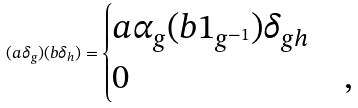<formula> <loc_0><loc_0><loc_500><loc_500>( a \delta _ { g } ) ( b \delta _ { h } ) = \begin{cases} a \alpha _ { g } ( b 1 _ { g ^ { - 1 } } ) \delta _ { g h } & \\ 0 & , \end{cases}</formula> 